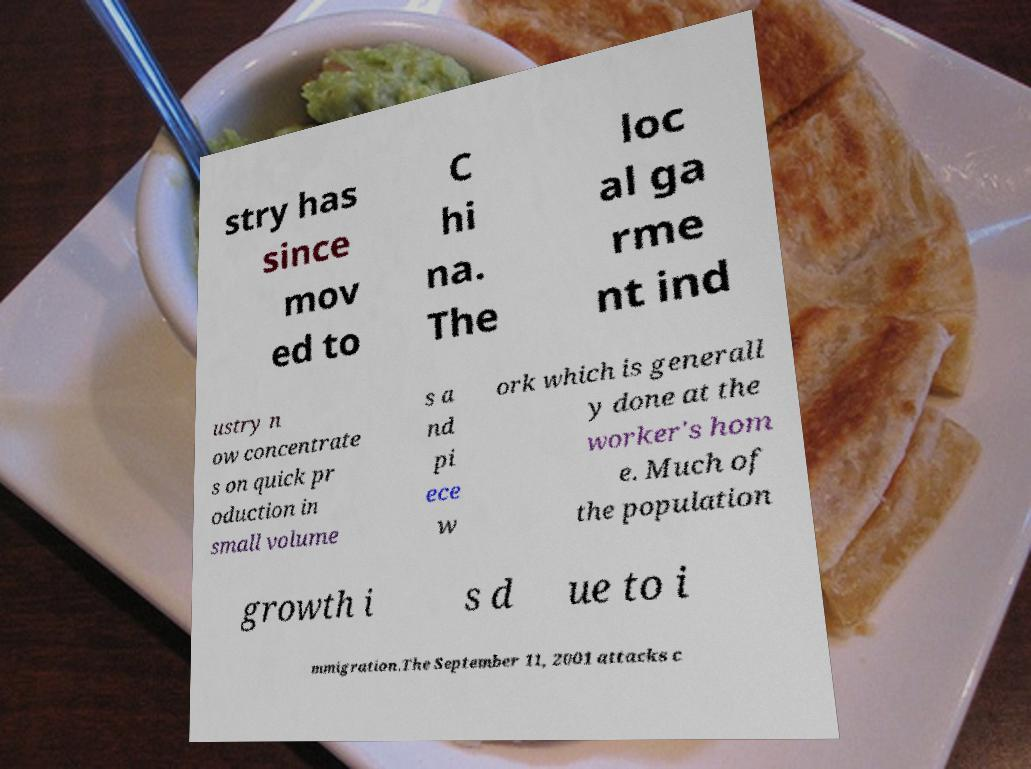There's text embedded in this image that I need extracted. Can you transcribe it verbatim? stry has since mov ed to C hi na. The loc al ga rme nt ind ustry n ow concentrate s on quick pr oduction in small volume s a nd pi ece w ork which is generall y done at the worker's hom e. Much of the population growth i s d ue to i mmigration.The September 11, 2001 attacks c 